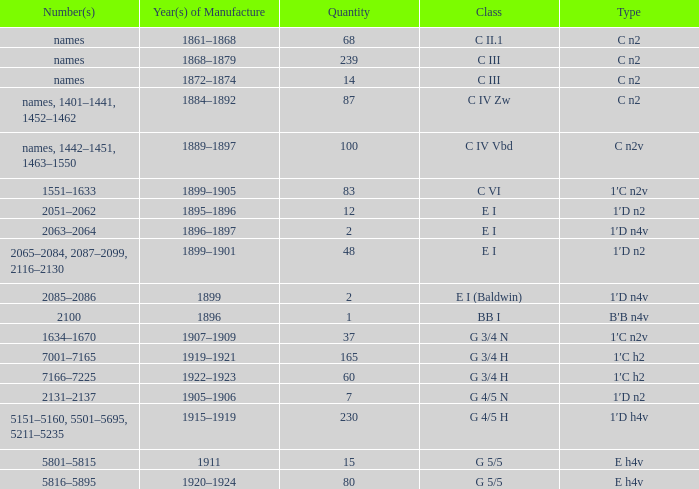Which Quantity has a Type of e h4v, and a Year(s) of Manufacture of 1920–1924? 80.0. 